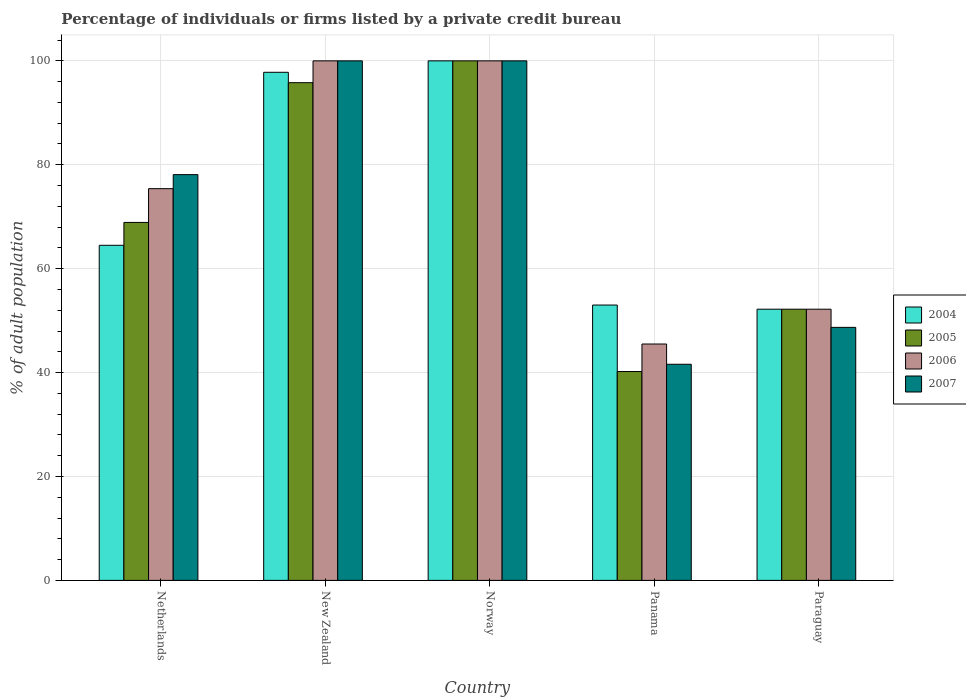How many groups of bars are there?
Your answer should be compact. 5. Are the number of bars on each tick of the X-axis equal?
Your response must be concise. Yes. How many bars are there on the 1st tick from the left?
Your response must be concise. 4. What is the label of the 1st group of bars from the left?
Your response must be concise. Netherlands. What is the percentage of population listed by a private credit bureau in 2006 in New Zealand?
Your answer should be compact. 100. Across all countries, what is the minimum percentage of population listed by a private credit bureau in 2004?
Your answer should be compact. 52.2. In which country was the percentage of population listed by a private credit bureau in 2006 minimum?
Your answer should be compact. Panama. What is the total percentage of population listed by a private credit bureau in 2006 in the graph?
Give a very brief answer. 373.1. What is the difference between the percentage of population listed by a private credit bureau in 2007 in Norway and that in Panama?
Keep it short and to the point. 58.4. What is the difference between the percentage of population listed by a private credit bureau in 2007 in New Zealand and the percentage of population listed by a private credit bureau in 2006 in Panama?
Provide a short and direct response. 54.5. What is the average percentage of population listed by a private credit bureau in 2007 per country?
Offer a very short reply. 73.68. What is the difference between the percentage of population listed by a private credit bureau of/in 2007 and percentage of population listed by a private credit bureau of/in 2004 in Paraguay?
Your answer should be compact. -3.5. In how many countries, is the percentage of population listed by a private credit bureau in 2007 greater than 4 %?
Your answer should be compact. 5. What is the ratio of the percentage of population listed by a private credit bureau in 2007 in Panama to that in Paraguay?
Make the answer very short. 0.85. Is the difference between the percentage of population listed by a private credit bureau in 2007 in Norway and Paraguay greater than the difference between the percentage of population listed by a private credit bureau in 2004 in Norway and Paraguay?
Your answer should be compact. Yes. What is the difference between the highest and the second highest percentage of population listed by a private credit bureau in 2007?
Provide a short and direct response. 21.9. What is the difference between the highest and the lowest percentage of population listed by a private credit bureau in 2004?
Your answer should be very brief. 47.8. Is it the case that in every country, the sum of the percentage of population listed by a private credit bureau in 2006 and percentage of population listed by a private credit bureau in 2005 is greater than the sum of percentage of population listed by a private credit bureau in 2007 and percentage of population listed by a private credit bureau in 2004?
Your response must be concise. No. How many bars are there?
Your answer should be very brief. 20. Does the graph contain any zero values?
Give a very brief answer. No. Does the graph contain grids?
Your response must be concise. Yes. What is the title of the graph?
Your answer should be very brief. Percentage of individuals or firms listed by a private credit bureau. Does "1982" appear as one of the legend labels in the graph?
Keep it short and to the point. No. What is the label or title of the X-axis?
Offer a very short reply. Country. What is the label or title of the Y-axis?
Offer a very short reply. % of adult population. What is the % of adult population in 2004 in Netherlands?
Your answer should be compact. 64.5. What is the % of adult population of 2005 in Netherlands?
Keep it short and to the point. 68.9. What is the % of adult population in 2006 in Netherlands?
Offer a terse response. 75.4. What is the % of adult population of 2007 in Netherlands?
Your answer should be very brief. 78.1. What is the % of adult population in 2004 in New Zealand?
Your response must be concise. 97.8. What is the % of adult population of 2005 in New Zealand?
Keep it short and to the point. 95.8. What is the % of adult population of 2006 in New Zealand?
Your response must be concise. 100. What is the % of adult population of 2007 in New Zealand?
Keep it short and to the point. 100. What is the % of adult population of 2005 in Norway?
Your answer should be very brief. 100. What is the % of adult population in 2007 in Norway?
Provide a short and direct response. 100. What is the % of adult population in 2005 in Panama?
Ensure brevity in your answer.  40.2. What is the % of adult population in 2006 in Panama?
Ensure brevity in your answer.  45.5. What is the % of adult population in 2007 in Panama?
Ensure brevity in your answer.  41.6. What is the % of adult population in 2004 in Paraguay?
Provide a short and direct response. 52.2. What is the % of adult population in 2005 in Paraguay?
Your answer should be compact. 52.2. What is the % of adult population in 2006 in Paraguay?
Keep it short and to the point. 52.2. What is the % of adult population in 2007 in Paraguay?
Offer a very short reply. 48.7. Across all countries, what is the maximum % of adult population in 2004?
Keep it short and to the point. 100. Across all countries, what is the maximum % of adult population in 2007?
Provide a short and direct response. 100. Across all countries, what is the minimum % of adult population of 2004?
Your answer should be very brief. 52.2. Across all countries, what is the minimum % of adult population in 2005?
Your response must be concise. 40.2. Across all countries, what is the minimum % of adult population of 2006?
Offer a very short reply. 45.5. Across all countries, what is the minimum % of adult population of 2007?
Offer a very short reply. 41.6. What is the total % of adult population of 2004 in the graph?
Your response must be concise. 367.5. What is the total % of adult population in 2005 in the graph?
Provide a short and direct response. 357.1. What is the total % of adult population in 2006 in the graph?
Your response must be concise. 373.1. What is the total % of adult population of 2007 in the graph?
Give a very brief answer. 368.4. What is the difference between the % of adult population in 2004 in Netherlands and that in New Zealand?
Offer a very short reply. -33.3. What is the difference between the % of adult population of 2005 in Netherlands and that in New Zealand?
Provide a succinct answer. -26.9. What is the difference between the % of adult population of 2006 in Netherlands and that in New Zealand?
Your response must be concise. -24.6. What is the difference between the % of adult population in 2007 in Netherlands and that in New Zealand?
Give a very brief answer. -21.9. What is the difference between the % of adult population of 2004 in Netherlands and that in Norway?
Make the answer very short. -35.5. What is the difference between the % of adult population of 2005 in Netherlands and that in Norway?
Your answer should be compact. -31.1. What is the difference between the % of adult population of 2006 in Netherlands and that in Norway?
Offer a terse response. -24.6. What is the difference between the % of adult population in 2007 in Netherlands and that in Norway?
Your answer should be very brief. -21.9. What is the difference between the % of adult population in 2005 in Netherlands and that in Panama?
Offer a terse response. 28.7. What is the difference between the % of adult population in 2006 in Netherlands and that in Panama?
Keep it short and to the point. 29.9. What is the difference between the % of adult population of 2007 in Netherlands and that in Panama?
Provide a succinct answer. 36.5. What is the difference between the % of adult population in 2004 in Netherlands and that in Paraguay?
Your answer should be very brief. 12.3. What is the difference between the % of adult population in 2005 in Netherlands and that in Paraguay?
Your response must be concise. 16.7. What is the difference between the % of adult population of 2006 in Netherlands and that in Paraguay?
Your answer should be compact. 23.2. What is the difference between the % of adult population of 2007 in Netherlands and that in Paraguay?
Make the answer very short. 29.4. What is the difference between the % of adult population of 2005 in New Zealand and that in Norway?
Your response must be concise. -4.2. What is the difference between the % of adult population of 2004 in New Zealand and that in Panama?
Your answer should be very brief. 44.8. What is the difference between the % of adult population of 2005 in New Zealand and that in Panama?
Give a very brief answer. 55.6. What is the difference between the % of adult population in 2006 in New Zealand and that in Panama?
Give a very brief answer. 54.5. What is the difference between the % of adult population in 2007 in New Zealand and that in Panama?
Offer a terse response. 58.4. What is the difference between the % of adult population of 2004 in New Zealand and that in Paraguay?
Provide a succinct answer. 45.6. What is the difference between the % of adult population in 2005 in New Zealand and that in Paraguay?
Provide a succinct answer. 43.6. What is the difference between the % of adult population of 2006 in New Zealand and that in Paraguay?
Your response must be concise. 47.8. What is the difference between the % of adult population in 2007 in New Zealand and that in Paraguay?
Your response must be concise. 51.3. What is the difference between the % of adult population in 2004 in Norway and that in Panama?
Offer a terse response. 47. What is the difference between the % of adult population in 2005 in Norway and that in Panama?
Give a very brief answer. 59.8. What is the difference between the % of adult population in 2006 in Norway and that in Panama?
Offer a very short reply. 54.5. What is the difference between the % of adult population in 2007 in Norway and that in Panama?
Provide a succinct answer. 58.4. What is the difference between the % of adult population of 2004 in Norway and that in Paraguay?
Offer a terse response. 47.8. What is the difference between the % of adult population in 2005 in Norway and that in Paraguay?
Offer a terse response. 47.8. What is the difference between the % of adult population in 2006 in Norway and that in Paraguay?
Ensure brevity in your answer.  47.8. What is the difference between the % of adult population of 2007 in Norway and that in Paraguay?
Offer a very short reply. 51.3. What is the difference between the % of adult population in 2006 in Panama and that in Paraguay?
Offer a terse response. -6.7. What is the difference between the % of adult population of 2007 in Panama and that in Paraguay?
Offer a very short reply. -7.1. What is the difference between the % of adult population of 2004 in Netherlands and the % of adult population of 2005 in New Zealand?
Make the answer very short. -31.3. What is the difference between the % of adult population in 2004 in Netherlands and the % of adult population in 2006 in New Zealand?
Your response must be concise. -35.5. What is the difference between the % of adult population in 2004 in Netherlands and the % of adult population in 2007 in New Zealand?
Give a very brief answer. -35.5. What is the difference between the % of adult population in 2005 in Netherlands and the % of adult population in 2006 in New Zealand?
Make the answer very short. -31.1. What is the difference between the % of adult population of 2005 in Netherlands and the % of adult population of 2007 in New Zealand?
Your answer should be compact. -31.1. What is the difference between the % of adult population in 2006 in Netherlands and the % of adult population in 2007 in New Zealand?
Ensure brevity in your answer.  -24.6. What is the difference between the % of adult population in 2004 in Netherlands and the % of adult population in 2005 in Norway?
Provide a succinct answer. -35.5. What is the difference between the % of adult population of 2004 in Netherlands and the % of adult population of 2006 in Norway?
Offer a terse response. -35.5. What is the difference between the % of adult population in 2004 in Netherlands and the % of adult population in 2007 in Norway?
Your answer should be compact. -35.5. What is the difference between the % of adult population in 2005 in Netherlands and the % of adult population in 2006 in Norway?
Provide a succinct answer. -31.1. What is the difference between the % of adult population of 2005 in Netherlands and the % of adult population of 2007 in Norway?
Offer a very short reply. -31.1. What is the difference between the % of adult population of 2006 in Netherlands and the % of adult population of 2007 in Norway?
Ensure brevity in your answer.  -24.6. What is the difference between the % of adult population in 2004 in Netherlands and the % of adult population in 2005 in Panama?
Make the answer very short. 24.3. What is the difference between the % of adult population in 2004 in Netherlands and the % of adult population in 2006 in Panama?
Your answer should be very brief. 19. What is the difference between the % of adult population in 2004 in Netherlands and the % of adult population in 2007 in Panama?
Your answer should be compact. 22.9. What is the difference between the % of adult population of 2005 in Netherlands and the % of adult population of 2006 in Panama?
Provide a succinct answer. 23.4. What is the difference between the % of adult population of 2005 in Netherlands and the % of adult population of 2007 in Panama?
Your response must be concise. 27.3. What is the difference between the % of adult population in 2006 in Netherlands and the % of adult population in 2007 in Panama?
Your answer should be compact. 33.8. What is the difference between the % of adult population in 2004 in Netherlands and the % of adult population in 2006 in Paraguay?
Provide a short and direct response. 12.3. What is the difference between the % of adult population of 2004 in Netherlands and the % of adult population of 2007 in Paraguay?
Offer a very short reply. 15.8. What is the difference between the % of adult population of 2005 in Netherlands and the % of adult population of 2006 in Paraguay?
Keep it short and to the point. 16.7. What is the difference between the % of adult population in 2005 in Netherlands and the % of adult population in 2007 in Paraguay?
Provide a succinct answer. 20.2. What is the difference between the % of adult population in 2006 in Netherlands and the % of adult population in 2007 in Paraguay?
Your response must be concise. 26.7. What is the difference between the % of adult population in 2004 in New Zealand and the % of adult population in 2007 in Norway?
Offer a terse response. -2.2. What is the difference between the % of adult population of 2005 in New Zealand and the % of adult population of 2006 in Norway?
Provide a short and direct response. -4.2. What is the difference between the % of adult population in 2005 in New Zealand and the % of adult population in 2007 in Norway?
Provide a short and direct response. -4.2. What is the difference between the % of adult population in 2004 in New Zealand and the % of adult population in 2005 in Panama?
Make the answer very short. 57.6. What is the difference between the % of adult population of 2004 in New Zealand and the % of adult population of 2006 in Panama?
Keep it short and to the point. 52.3. What is the difference between the % of adult population of 2004 in New Zealand and the % of adult population of 2007 in Panama?
Offer a terse response. 56.2. What is the difference between the % of adult population of 2005 in New Zealand and the % of adult population of 2006 in Panama?
Provide a succinct answer. 50.3. What is the difference between the % of adult population of 2005 in New Zealand and the % of adult population of 2007 in Panama?
Provide a short and direct response. 54.2. What is the difference between the % of adult population of 2006 in New Zealand and the % of adult population of 2007 in Panama?
Your response must be concise. 58.4. What is the difference between the % of adult population of 2004 in New Zealand and the % of adult population of 2005 in Paraguay?
Offer a very short reply. 45.6. What is the difference between the % of adult population of 2004 in New Zealand and the % of adult population of 2006 in Paraguay?
Make the answer very short. 45.6. What is the difference between the % of adult population in 2004 in New Zealand and the % of adult population in 2007 in Paraguay?
Offer a very short reply. 49.1. What is the difference between the % of adult population of 2005 in New Zealand and the % of adult population of 2006 in Paraguay?
Give a very brief answer. 43.6. What is the difference between the % of adult population in 2005 in New Zealand and the % of adult population in 2007 in Paraguay?
Your answer should be compact. 47.1. What is the difference between the % of adult population in 2006 in New Zealand and the % of adult population in 2007 in Paraguay?
Your response must be concise. 51.3. What is the difference between the % of adult population in 2004 in Norway and the % of adult population in 2005 in Panama?
Your answer should be very brief. 59.8. What is the difference between the % of adult population in 2004 in Norway and the % of adult population in 2006 in Panama?
Offer a terse response. 54.5. What is the difference between the % of adult population of 2004 in Norway and the % of adult population of 2007 in Panama?
Make the answer very short. 58.4. What is the difference between the % of adult population in 2005 in Norway and the % of adult population in 2006 in Panama?
Your response must be concise. 54.5. What is the difference between the % of adult population in 2005 in Norway and the % of adult population in 2007 in Panama?
Provide a succinct answer. 58.4. What is the difference between the % of adult population in 2006 in Norway and the % of adult population in 2007 in Panama?
Make the answer very short. 58.4. What is the difference between the % of adult population in 2004 in Norway and the % of adult population in 2005 in Paraguay?
Keep it short and to the point. 47.8. What is the difference between the % of adult population of 2004 in Norway and the % of adult population of 2006 in Paraguay?
Make the answer very short. 47.8. What is the difference between the % of adult population of 2004 in Norway and the % of adult population of 2007 in Paraguay?
Keep it short and to the point. 51.3. What is the difference between the % of adult population of 2005 in Norway and the % of adult population of 2006 in Paraguay?
Your answer should be very brief. 47.8. What is the difference between the % of adult population of 2005 in Norway and the % of adult population of 2007 in Paraguay?
Provide a short and direct response. 51.3. What is the difference between the % of adult population of 2006 in Norway and the % of adult population of 2007 in Paraguay?
Provide a succinct answer. 51.3. What is the difference between the % of adult population of 2004 in Panama and the % of adult population of 2007 in Paraguay?
Your response must be concise. 4.3. What is the difference between the % of adult population of 2005 in Panama and the % of adult population of 2006 in Paraguay?
Your answer should be very brief. -12. What is the difference between the % of adult population in 2005 in Panama and the % of adult population in 2007 in Paraguay?
Ensure brevity in your answer.  -8.5. What is the average % of adult population in 2004 per country?
Offer a terse response. 73.5. What is the average % of adult population in 2005 per country?
Provide a short and direct response. 71.42. What is the average % of adult population in 2006 per country?
Keep it short and to the point. 74.62. What is the average % of adult population of 2007 per country?
Give a very brief answer. 73.68. What is the difference between the % of adult population in 2004 and % of adult population in 2005 in Netherlands?
Make the answer very short. -4.4. What is the difference between the % of adult population in 2005 and % of adult population in 2007 in Netherlands?
Keep it short and to the point. -9.2. What is the difference between the % of adult population of 2006 and % of adult population of 2007 in Netherlands?
Offer a terse response. -2.7. What is the difference between the % of adult population in 2004 and % of adult population in 2005 in New Zealand?
Give a very brief answer. 2. What is the difference between the % of adult population of 2005 and % of adult population of 2007 in New Zealand?
Your answer should be compact. -4.2. What is the difference between the % of adult population in 2006 and % of adult population in 2007 in New Zealand?
Your answer should be compact. 0. What is the difference between the % of adult population in 2005 and % of adult population in 2007 in Norway?
Make the answer very short. 0. What is the difference between the % of adult population of 2006 and % of adult population of 2007 in Norway?
Offer a terse response. 0. What is the difference between the % of adult population of 2004 and % of adult population of 2006 in Panama?
Make the answer very short. 7.5. What is the difference between the % of adult population of 2004 and % of adult population of 2007 in Panama?
Ensure brevity in your answer.  11.4. What is the difference between the % of adult population in 2005 and % of adult population in 2006 in Panama?
Provide a succinct answer. -5.3. What is the difference between the % of adult population in 2005 and % of adult population in 2007 in Panama?
Ensure brevity in your answer.  -1.4. What is the difference between the % of adult population of 2006 and % of adult population of 2007 in Panama?
Offer a very short reply. 3.9. What is the difference between the % of adult population of 2004 and % of adult population of 2006 in Paraguay?
Your response must be concise. 0. What is the difference between the % of adult population of 2005 and % of adult population of 2007 in Paraguay?
Make the answer very short. 3.5. What is the ratio of the % of adult population in 2004 in Netherlands to that in New Zealand?
Your answer should be compact. 0.66. What is the ratio of the % of adult population in 2005 in Netherlands to that in New Zealand?
Keep it short and to the point. 0.72. What is the ratio of the % of adult population of 2006 in Netherlands to that in New Zealand?
Keep it short and to the point. 0.75. What is the ratio of the % of adult population in 2007 in Netherlands to that in New Zealand?
Keep it short and to the point. 0.78. What is the ratio of the % of adult population of 2004 in Netherlands to that in Norway?
Your answer should be very brief. 0.65. What is the ratio of the % of adult population in 2005 in Netherlands to that in Norway?
Give a very brief answer. 0.69. What is the ratio of the % of adult population in 2006 in Netherlands to that in Norway?
Your answer should be very brief. 0.75. What is the ratio of the % of adult population in 2007 in Netherlands to that in Norway?
Ensure brevity in your answer.  0.78. What is the ratio of the % of adult population of 2004 in Netherlands to that in Panama?
Your answer should be compact. 1.22. What is the ratio of the % of adult population of 2005 in Netherlands to that in Panama?
Provide a succinct answer. 1.71. What is the ratio of the % of adult population in 2006 in Netherlands to that in Panama?
Offer a very short reply. 1.66. What is the ratio of the % of adult population of 2007 in Netherlands to that in Panama?
Provide a succinct answer. 1.88. What is the ratio of the % of adult population of 2004 in Netherlands to that in Paraguay?
Keep it short and to the point. 1.24. What is the ratio of the % of adult population in 2005 in Netherlands to that in Paraguay?
Give a very brief answer. 1.32. What is the ratio of the % of adult population of 2006 in Netherlands to that in Paraguay?
Offer a terse response. 1.44. What is the ratio of the % of adult population of 2007 in Netherlands to that in Paraguay?
Your answer should be compact. 1.6. What is the ratio of the % of adult population of 2005 in New Zealand to that in Norway?
Make the answer very short. 0.96. What is the ratio of the % of adult population in 2004 in New Zealand to that in Panama?
Provide a succinct answer. 1.85. What is the ratio of the % of adult population in 2005 in New Zealand to that in Panama?
Give a very brief answer. 2.38. What is the ratio of the % of adult population in 2006 in New Zealand to that in Panama?
Offer a very short reply. 2.2. What is the ratio of the % of adult population of 2007 in New Zealand to that in Panama?
Provide a short and direct response. 2.4. What is the ratio of the % of adult population in 2004 in New Zealand to that in Paraguay?
Offer a terse response. 1.87. What is the ratio of the % of adult population in 2005 in New Zealand to that in Paraguay?
Your answer should be very brief. 1.84. What is the ratio of the % of adult population in 2006 in New Zealand to that in Paraguay?
Keep it short and to the point. 1.92. What is the ratio of the % of adult population of 2007 in New Zealand to that in Paraguay?
Your answer should be very brief. 2.05. What is the ratio of the % of adult population in 2004 in Norway to that in Panama?
Your answer should be very brief. 1.89. What is the ratio of the % of adult population in 2005 in Norway to that in Panama?
Keep it short and to the point. 2.49. What is the ratio of the % of adult population in 2006 in Norway to that in Panama?
Keep it short and to the point. 2.2. What is the ratio of the % of adult population of 2007 in Norway to that in Panama?
Offer a very short reply. 2.4. What is the ratio of the % of adult population in 2004 in Norway to that in Paraguay?
Offer a terse response. 1.92. What is the ratio of the % of adult population in 2005 in Norway to that in Paraguay?
Offer a very short reply. 1.92. What is the ratio of the % of adult population of 2006 in Norway to that in Paraguay?
Provide a short and direct response. 1.92. What is the ratio of the % of adult population in 2007 in Norway to that in Paraguay?
Give a very brief answer. 2.05. What is the ratio of the % of adult population of 2004 in Panama to that in Paraguay?
Make the answer very short. 1.02. What is the ratio of the % of adult population in 2005 in Panama to that in Paraguay?
Offer a very short reply. 0.77. What is the ratio of the % of adult population in 2006 in Panama to that in Paraguay?
Provide a succinct answer. 0.87. What is the ratio of the % of adult population of 2007 in Panama to that in Paraguay?
Ensure brevity in your answer.  0.85. What is the difference between the highest and the second highest % of adult population in 2005?
Offer a terse response. 4.2. What is the difference between the highest and the lowest % of adult population in 2004?
Offer a terse response. 47.8. What is the difference between the highest and the lowest % of adult population of 2005?
Make the answer very short. 59.8. What is the difference between the highest and the lowest % of adult population of 2006?
Provide a short and direct response. 54.5. What is the difference between the highest and the lowest % of adult population of 2007?
Offer a very short reply. 58.4. 